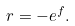<formula> <loc_0><loc_0><loc_500><loc_500>r = - e ^ { f } .</formula> 